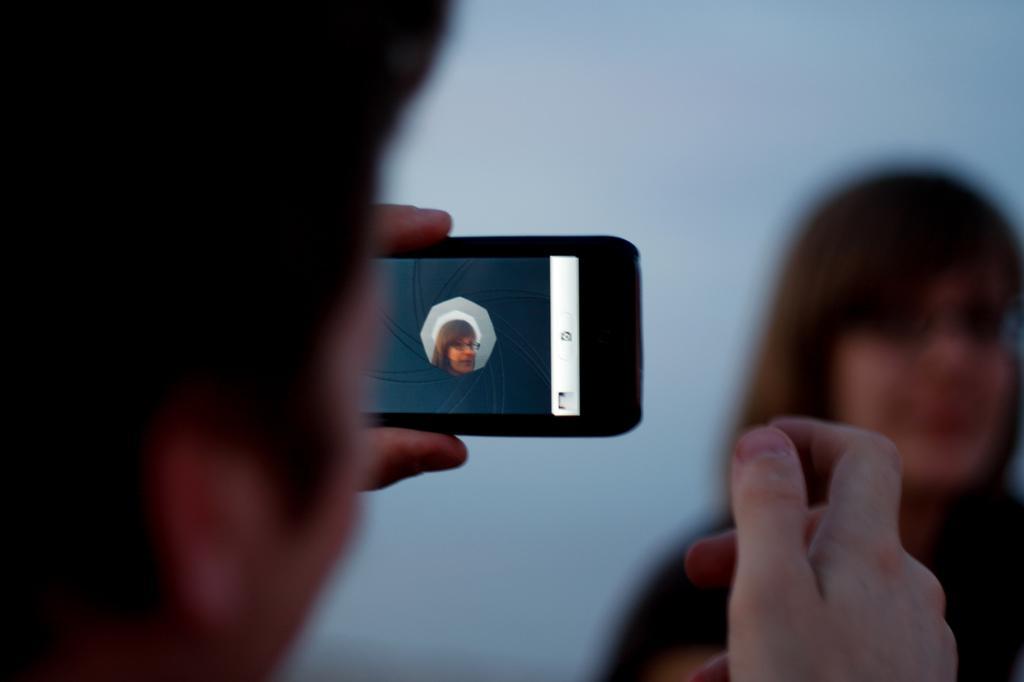In one or two sentences, can you explain what this image depicts? On the left side, there is a person holding a mobile with a hand and capturing a woman who is wearing a spectacle. And the background is blurred. 